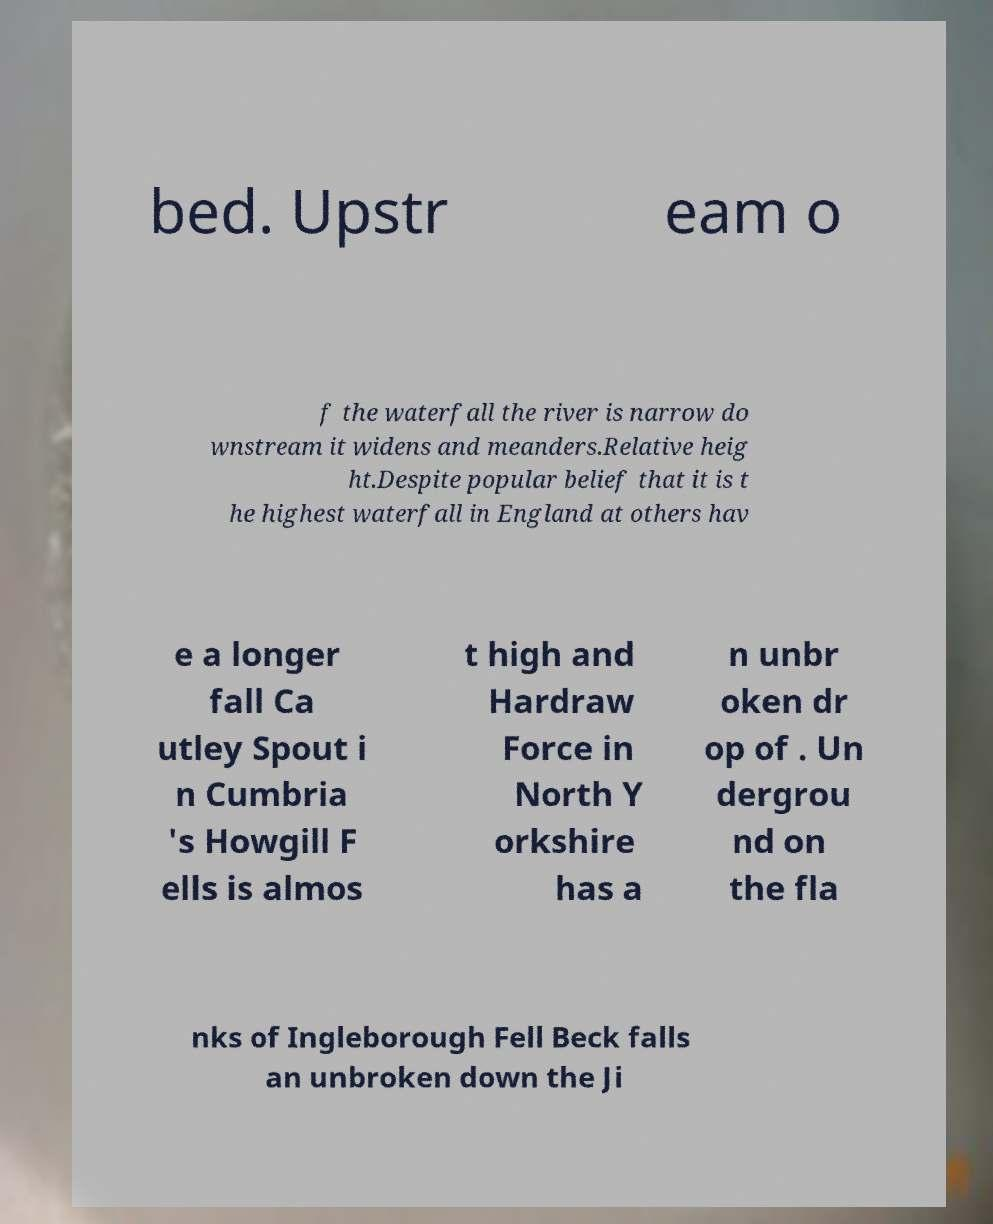For documentation purposes, I need the text within this image transcribed. Could you provide that? bed. Upstr eam o f the waterfall the river is narrow do wnstream it widens and meanders.Relative heig ht.Despite popular belief that it is t he highest waterfall in England at others hav e a longer fall Ca utley Spout i n Cumbria 's Howgill F ells is almos t high and Hardraw Force in North Y orkshire has a n unbr oken dr op of . Un dergrou nd on the fla nks of Ingleborough Fell Beck falls an unbroken down the Ji 